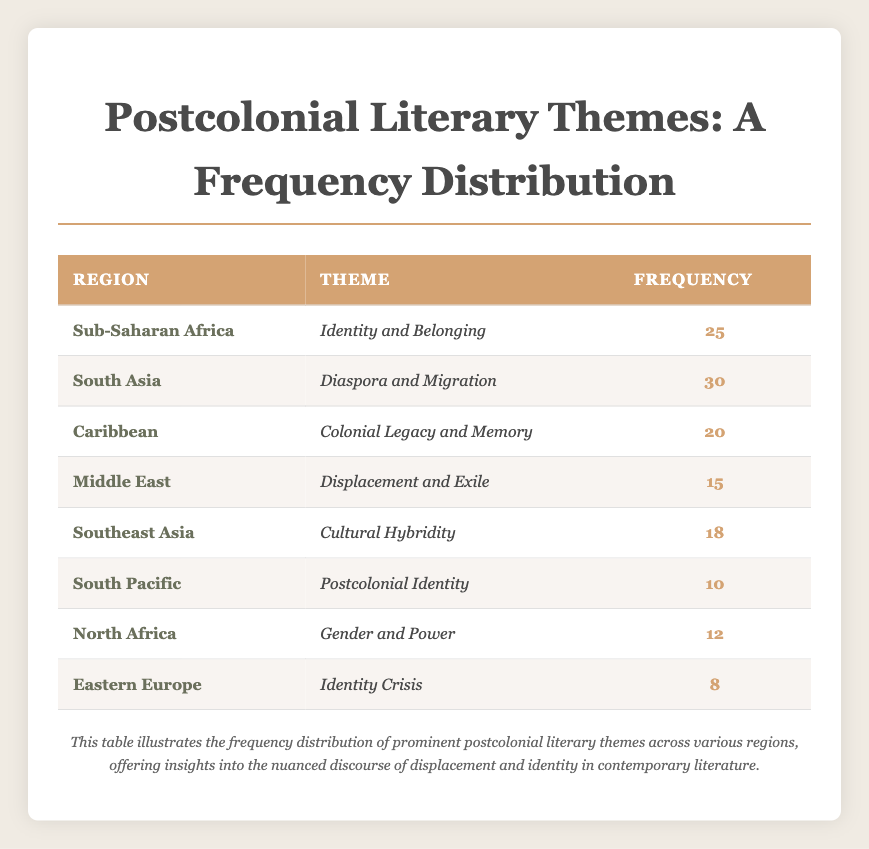What is the most frequent theme in South Asia? The table indicates that the most frequent theme in South Asia is "Diaspora and Migration" with a frequency of 30.
Answer: Diaspora and Migration Which region has the theme of "Postcolonial Identity"? The table shows that the South Pacific region is associated with the theme "Postcolonial Identity," which has a frequency of 10.
Answer: South Pacific How many regions have a frequency of 15 or higher? By examining the frequencies listed in the table, the regions with a frequency of 15 or higher are Sub-Saharan Africa (25), South Asia (30), Caribbean (20), Middle East (15), and Southeast Asia (18), totaling five regions.
Answer: 5 What is the difference in frequency between the theme "Colonial Legacy and Memory" and "Gender and Power"? "Colonial Legacy and Memory" in the Caribbean has a frequency of 20, while "Gender and Power" in North Africa has a frequency of 12. The difference is 20 - 12 = 8.
Answer: 8 Is "Identity Crisis" the theme with the lowest frequency? By checking the frequencies, "Identity Crisis" has a frequency of 8, which is indeed the lowest compared to others in the table.
Answer: Yes What is the average frequency of the themes listed in the table? To calculate the average, we sum the frequencies (25 + 30 + 20 + 15 + 18 + 10 + 12 + 8 = 138) and divide by the number of themes (8), yielding the average frequency of 138/8 = 17.25.
Answer: 17.25 